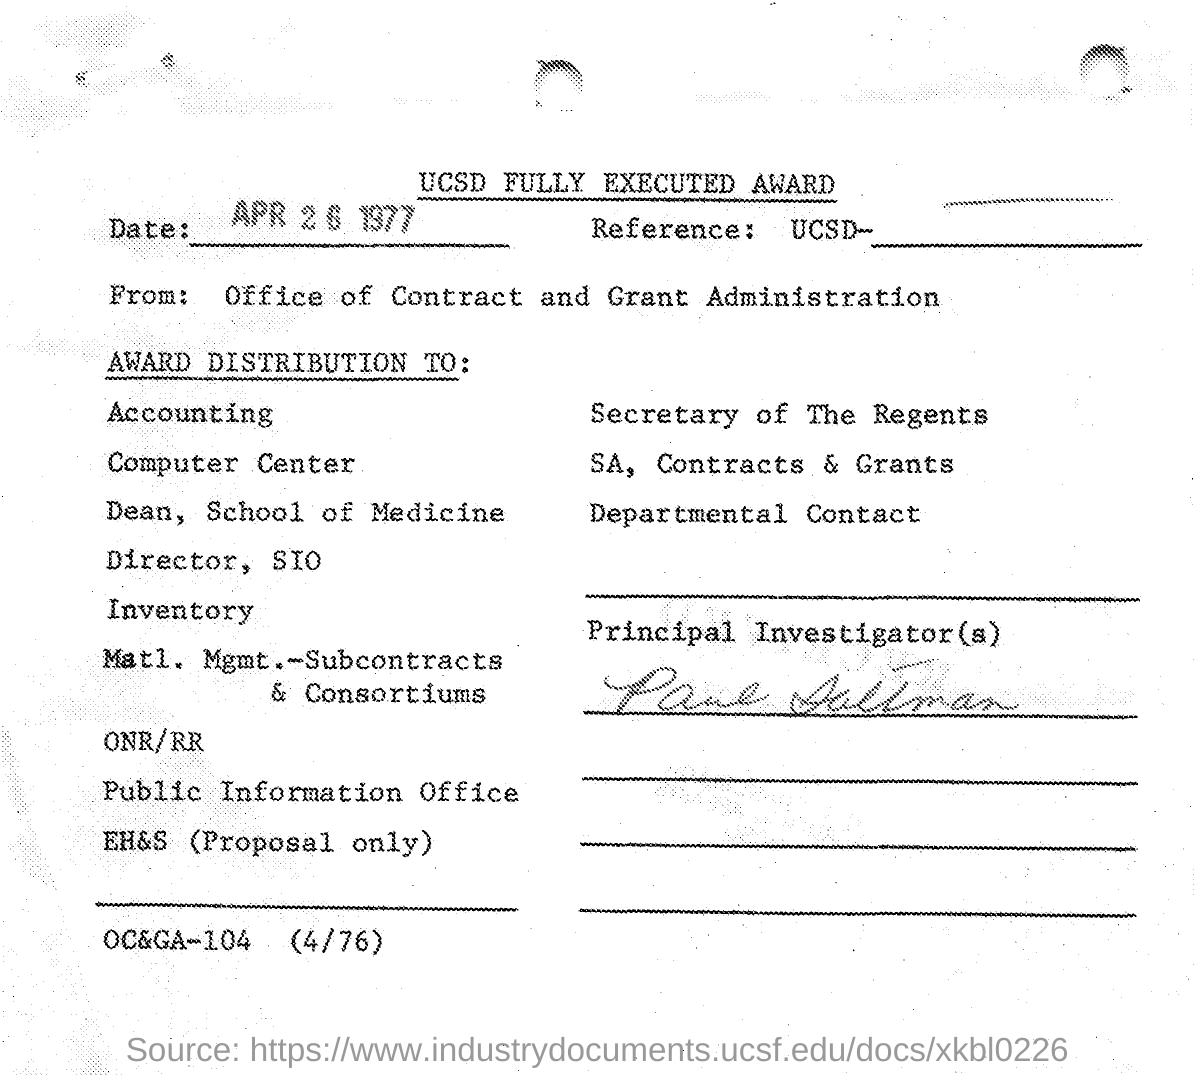What is the date mentioned in the given page ?
Your answer should be compact. Apr 26 1977. From whom this letter was delivered ?
Offer a terse response. Office of Contract and Grant Administration. 